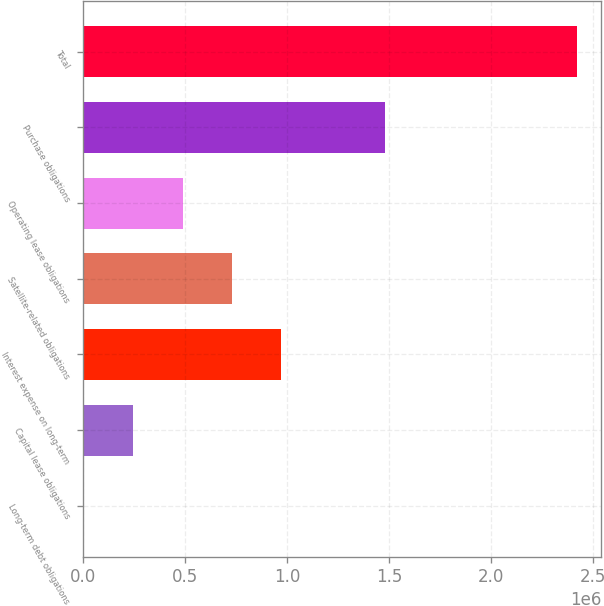Convert chart to OTSL. <chart><loc_0><loc_0><loc_500><loc_500><bar_chart><fcel>Long-term debt obligations<fcel>Capital lease obligations<fcel>Interest expense on long-term<fcel>Satellite-related obligations<fcel>Operating lease obligations<fcel>Purchase obligations<fcel>Total<nl><fcel>6443<fcel>247722<fcel>971560<fcel>730281<fcel>489002<fcel>1.48101e+06<fcel>2.41924e+06<nl></chart> 